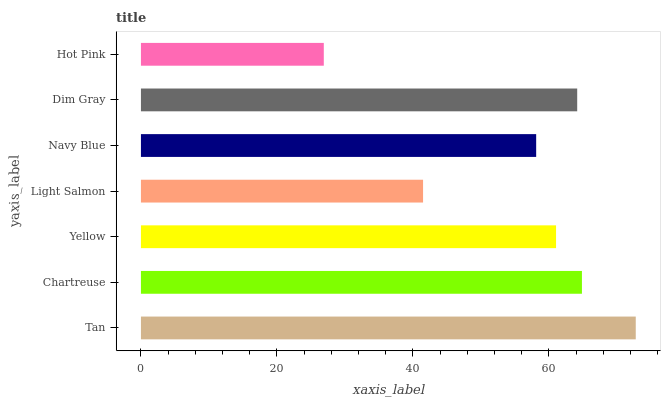Is Hot Pink the minimum?
Answer yes or no. Yes. Is Tan the maximum?
Answer yes or no. Yes. Is Chartreuse the minimum?
Answer yes or no. No. Is Chartreuse the maximum?
Answer yes or no. No. Is Tan greater than Chartreuse?
Answer yes or no. Yes. Is Chartreuse less than Tan?
Answer yes or no. Yes. Is Chartreuse greater than Tan?
Answer yes or no. No. Is Tan less than Chartreuse?
Answer yes or no. No. Is Yellow the high median?
Answer yes or no. Yes. Is Yellow the low median?
Answer yes or no. Yes. Is Tan the high median?
Answer yes or no. No. Is Hot Pink the low median?
Answer yes or no. No. 